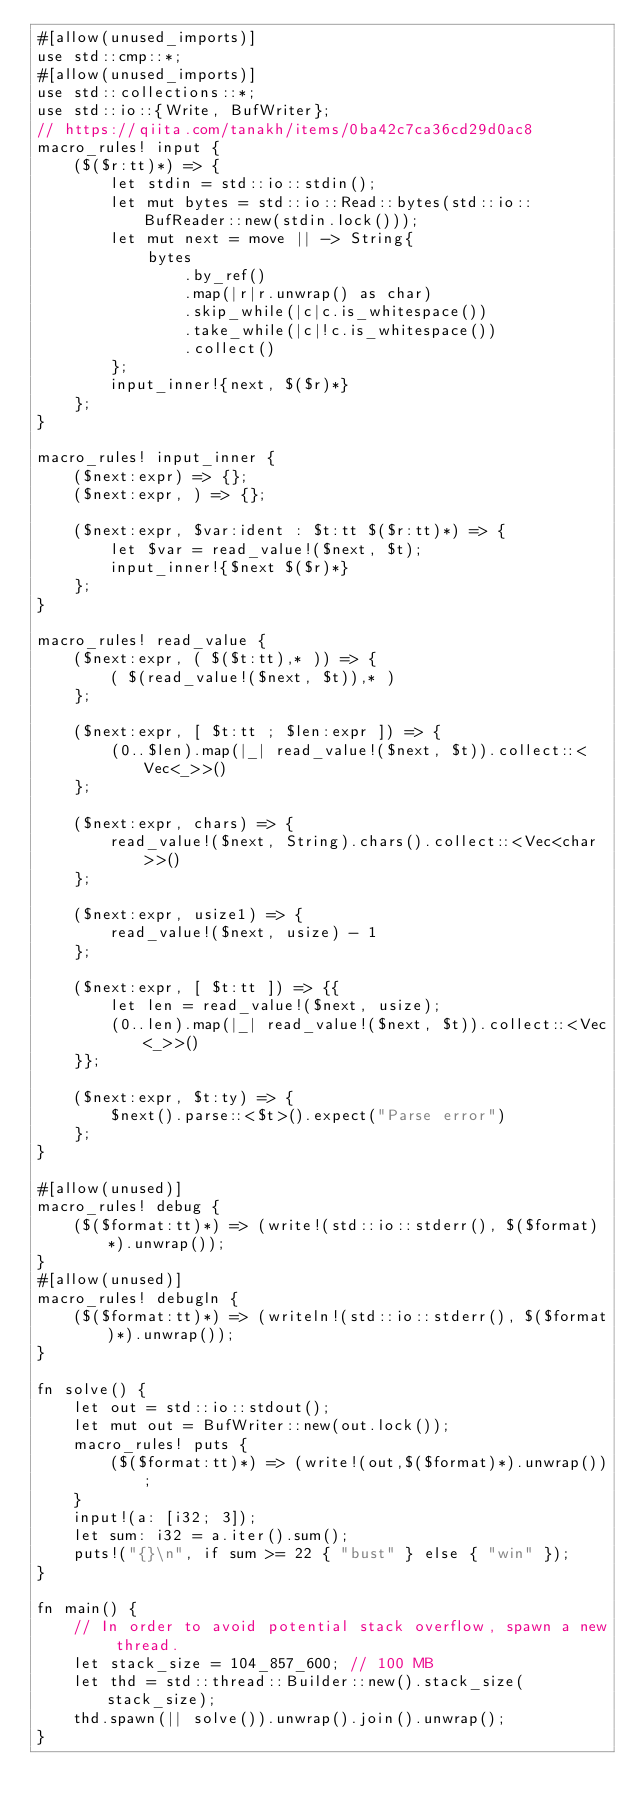Convert code to text. <code><loc_0><loc_0><loc_500><loc_500><_Rust_>#[allow(unused_imports)]
use std::cmp::*;
#[allow(unused_imports)]
use std::collections::*;
use std::io::{Write, BufWriter};
// https://qiita.com/tanakh/items/0ba42c7ca36cd29d0ac8
macro_rules! input {
    ($($r:tt)*) => {
        let stdin = std::io::stdin();
        let mut bytes = std::io::Read::bytes(std::io::BufReader::new(stdin.lock()));
        let mut next = move || -> String{
            bytes
                .by_ref()
                .map(|r|r.unwrap() as char)
                .skip_while(|c|c.is_whitespace())
                .take_while(|c|!c.is_whitespace())
                .collect()
        };
        input_inner!{next, $($r)*}
    };
}

macro_rules! input_inner {
    ($next:expr) => {};
    ($next:expr, ) => {};

    ($next:expr, $var:ident : $t:tt $($r:tt)*) => {
        let $var = read_value!($next, $t);
        input_inner!{$next $($r)*}
    };
}

macro_rules! read_value {
    ($next:expr, ( $($t:tt),* )) => {
        ( $(read_value!($next, $t)),* )
    };

    ($next:expr, [ $t:tt ; $len:expr ]) => {
        (0..$len).map(|_| read_value!($next, $t)).collect::<Vec<_>>()
    };

    ($next:expr, chars) => {
        read_value!($next, String).chars().collect::<Vec<char>>()
    };

    ($next:expr, usize1) => {
        read_value!($next, usize) - 1
    };

    ($next:expr, [ $t:tt ]) => {{
        let len = read_value!($next, usize);
        (0..len).map(|_| read_value!($next, $t)).collect::<Vec<_>>()
    }};

    ($next:expr, $t:ty) => {
        $next().parse::<$t>().expect("Parse error")
    };
}

#[allow(unused)]
macro_rules! debug {
    ($($format:tt)*) => (write!(std::io::stderr(), $($format)*).unwrap());
}
#[allow(unused)]
macro_rules! debugln {
    ($($format:tt)*) => (writeln!(std::io::stderr(), $($format)*).unwrap());
}

fn solve() {
    let out = std::io::stdout();
    let mut out = BufWriter::new(out.lock());
    macro_rules! puts {
        ($($format:tt)*) => (write!(out,$($format)*).unwrap());
    }
    input!(a: [i32; 3]);
    let sum: i32 = a.iter().sum();
    puts!("{}\n", if sum >= 22 { "bust" } else { "win" });
}

fn main() {
    // In order to avoid potential stack overflow, spawn a new thread.
    let stack_size = 104_857_600; // 100 MB
    let thd = std::thread::Builder::new().stack_size(stack_size);
    thd.spawn(|| solve()).unwrap().join().unwrap();
}
</code> 